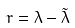Convert formula to latex. <formula><loc_0><loc_0><loc_500><loc_500>r = \lambda - \tilde { \lambda }</formula> 